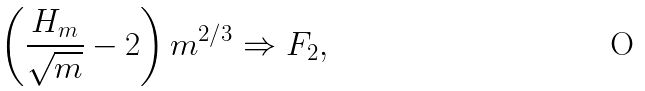<formula> <loc_0><loc_0><loc_500><loc_500>\left ( \frac { H _ { m } } { \sqrt { m } } - 2 \right ) m ^ { 2 / 3 } \Rightarrow F _ { 2 } ,</formula> 